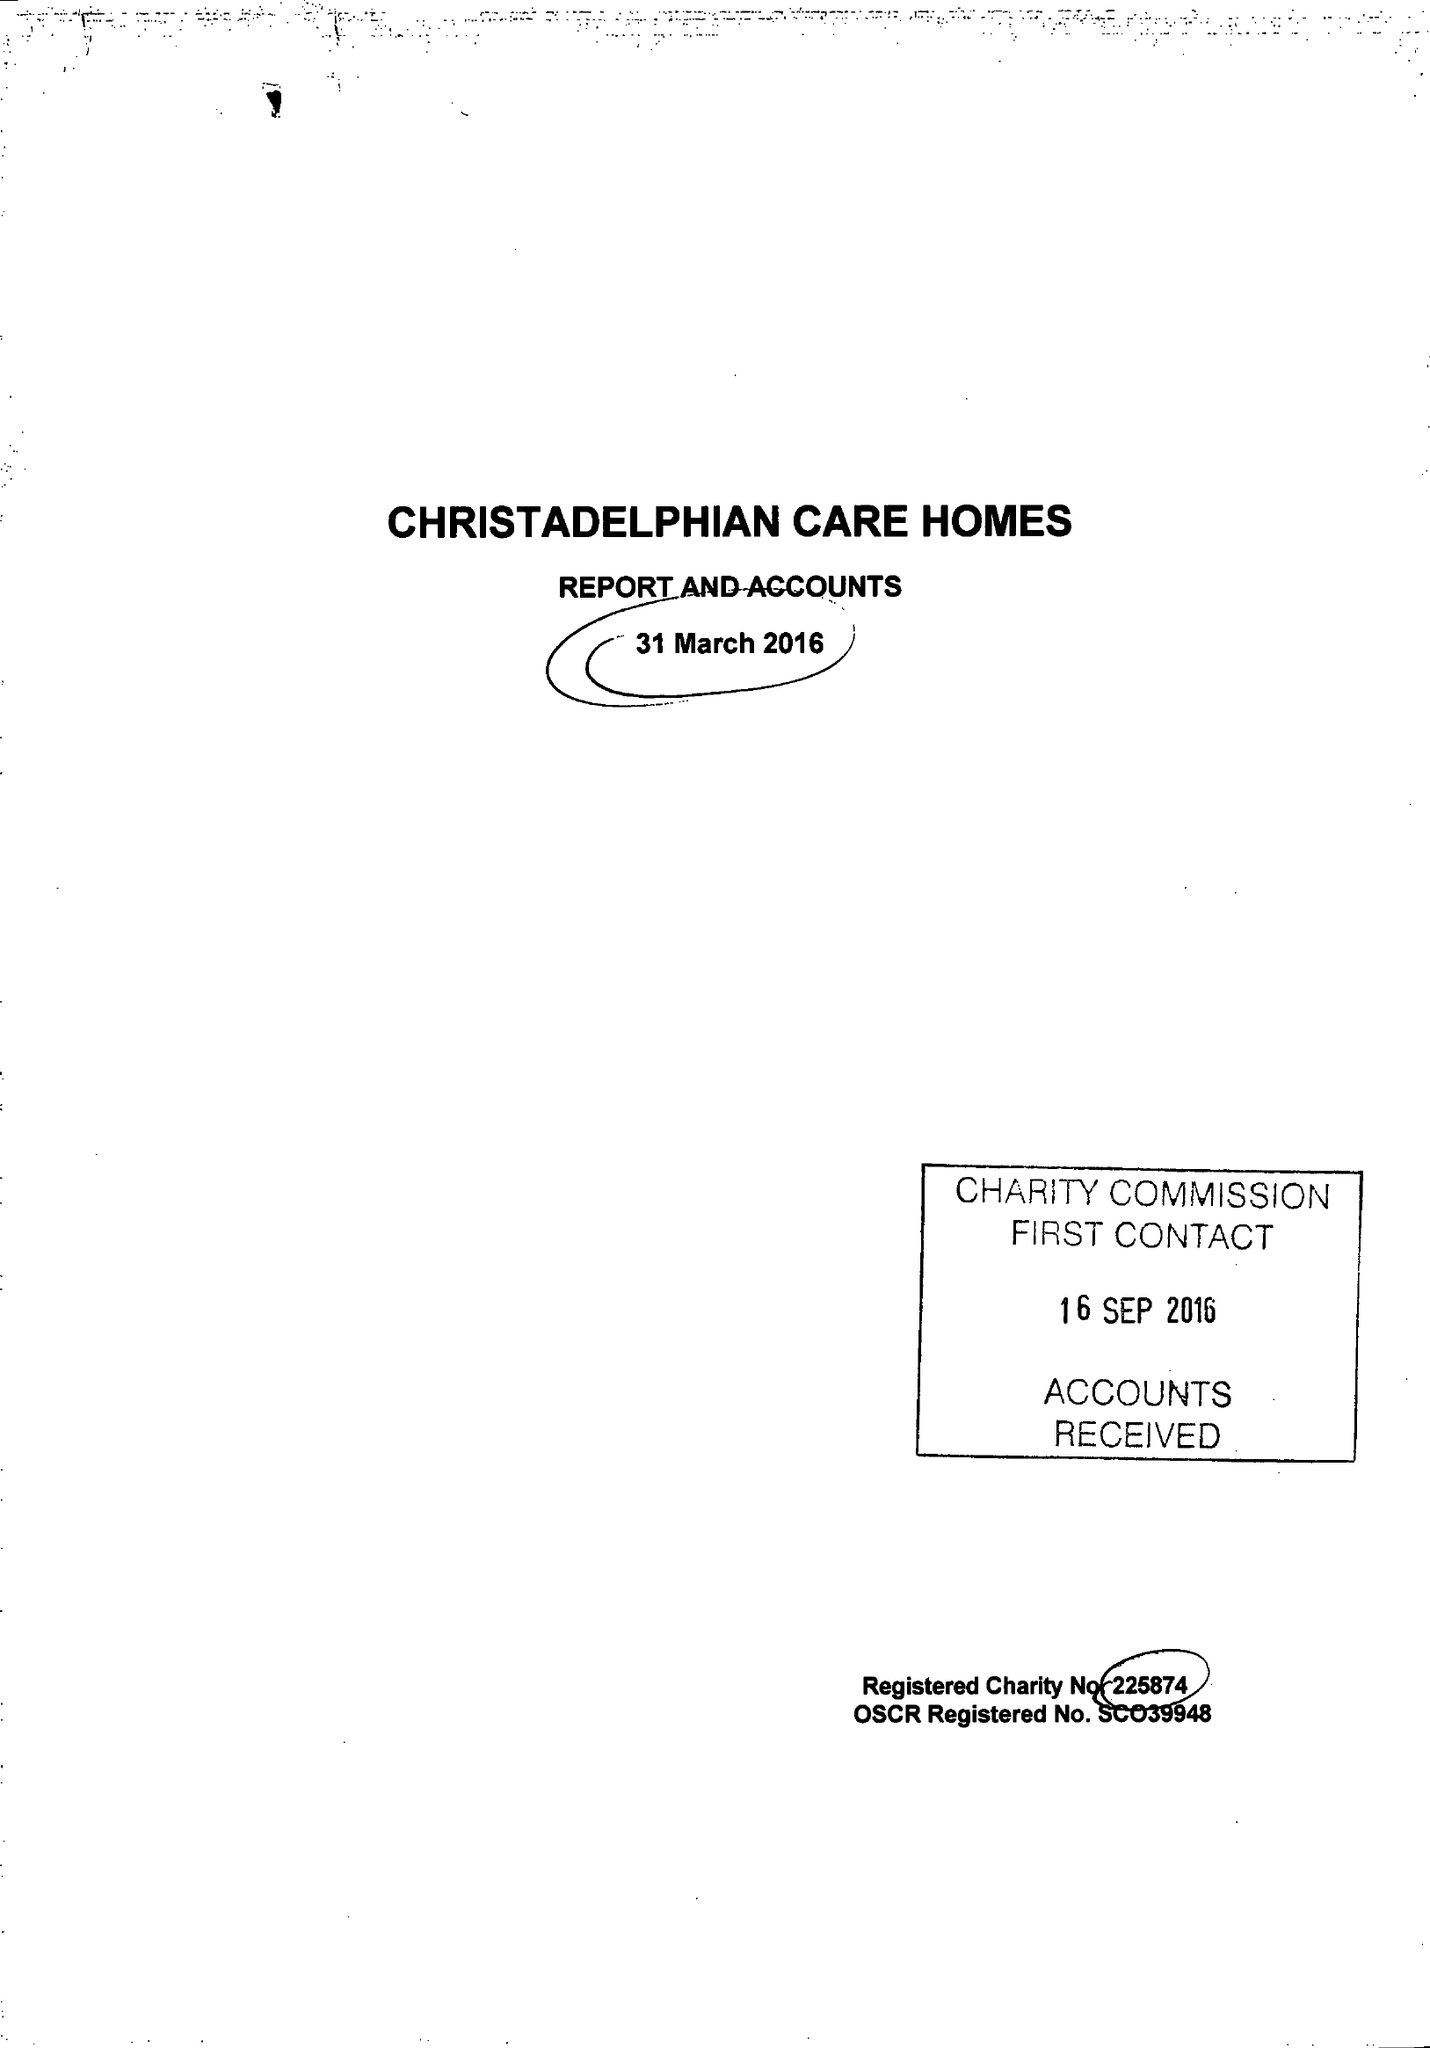What is the value for the address__postcode?
Answer the question using a single word or phrase. B27 6AD 